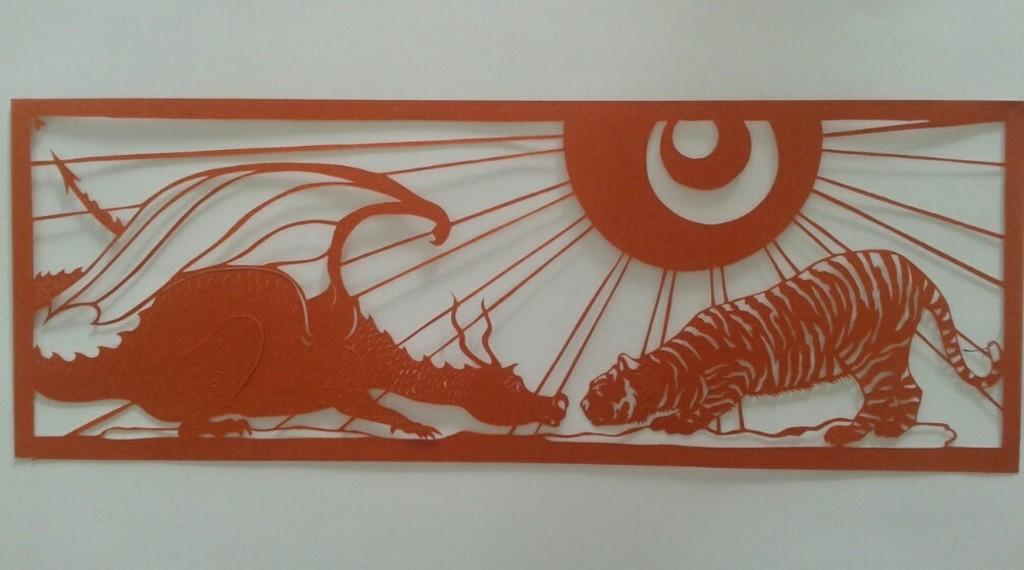What is the main subject in the image? There is a painting in the image. Can you describe the background of the painting? The painting is on a white-colored wall. What type of friction can be seen between the painting and the wall in the image? There is no friction visible between the painting and the wall in the image. What is the way the father is depicted in the painting? There is no father depicted in the painting, as the image only shows a painting on a white-colored wall. 